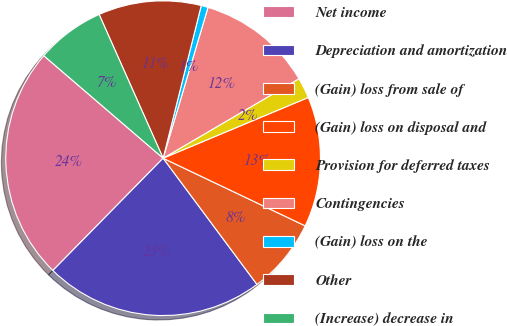Convert chart to OTSL. <chart><loc_0><loc_0><loc_500><loc_500><pie_chart><fcel>Net income<fcel>Depreciation and amortization<fcel>(Gain) loss from sale of<fcel>(Gain) loss on disposal and<fcel>Provision for deferred taxes<fcel>Contingencies<fcel>(Gain) loss on the<fcel>Other<fcel>(Increase) decrease in<nl><fcel>23.94%<fcel>22.53%<fcel>7.75%<fcel>13.38%<fcel>2.12%<fcel>11.97%<fcel>0.71%<fcel>10.56%<fcel>7.04%<nl></chart> 